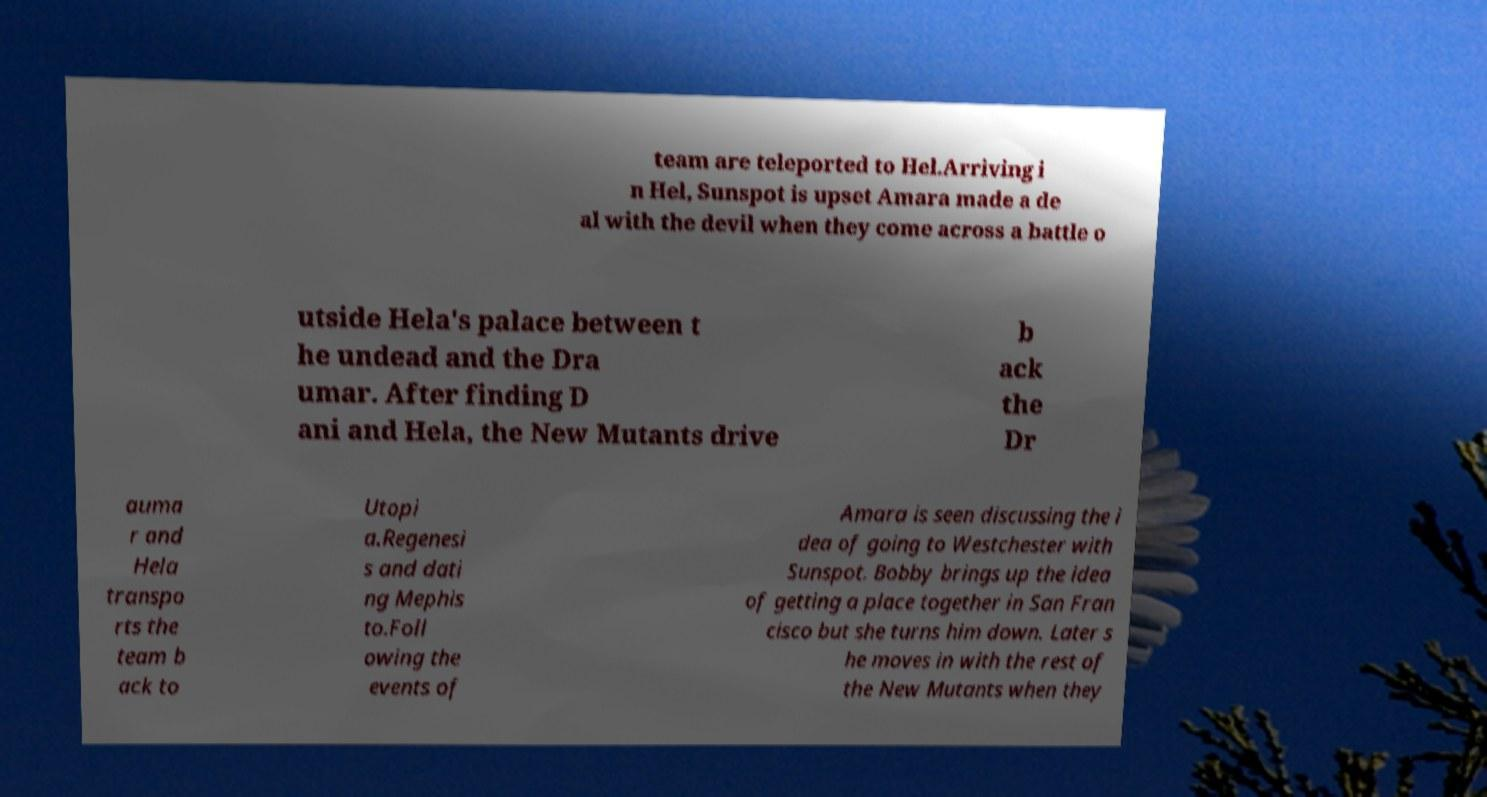Could you extract and type out the text from this image? team are teleported to Hel.Arriving i n Hel, Sunspot is upset Amara made a de al with the devil when they come across a battle o utside Hela's palace between t he undead and the Dra umar. After finding D ani and Hela, the New Mutants drive b ack the Dr auma r and Hela transpo rts the team b ack to Utopi a.Regenesi s and dati ng Mephis to.Foll owing the events of Amara is seen discussing the i dea of going to Westchester with Sunspot. Bobby brings up the idea of getting a place together in San Fran cisco but she turns him down. Later s he moves in with the rest of the New Mutants when they 